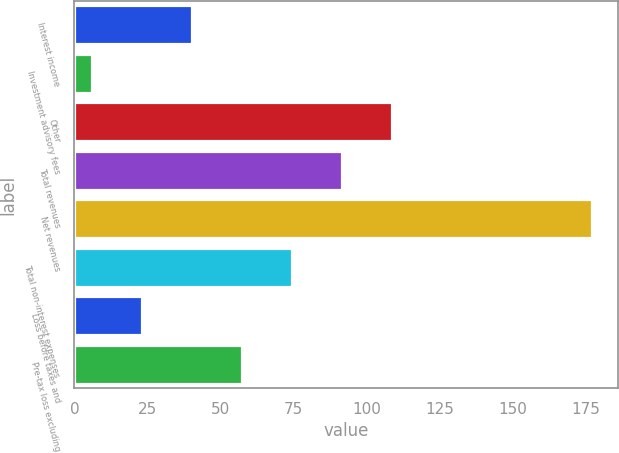Convert chart to OTSL. <chart><loc_0><loc_0><loc_500><loc_500><bar_chart><fcel>Interest income<fcel>Investment advisory fees<fcel>Other<fcel>Total revenues<fcel>Net revenues<fcel>Total non-interest expenses<fcel>Loss before taxes and<fcel>Pre-tax loss excluding<nl><fcel>40.2<fcel>6<fcel>108.6<fcel>91.5<fcel>177<fcel>74.4<fcel>23.1<fcel>57.3<nl></chart> 